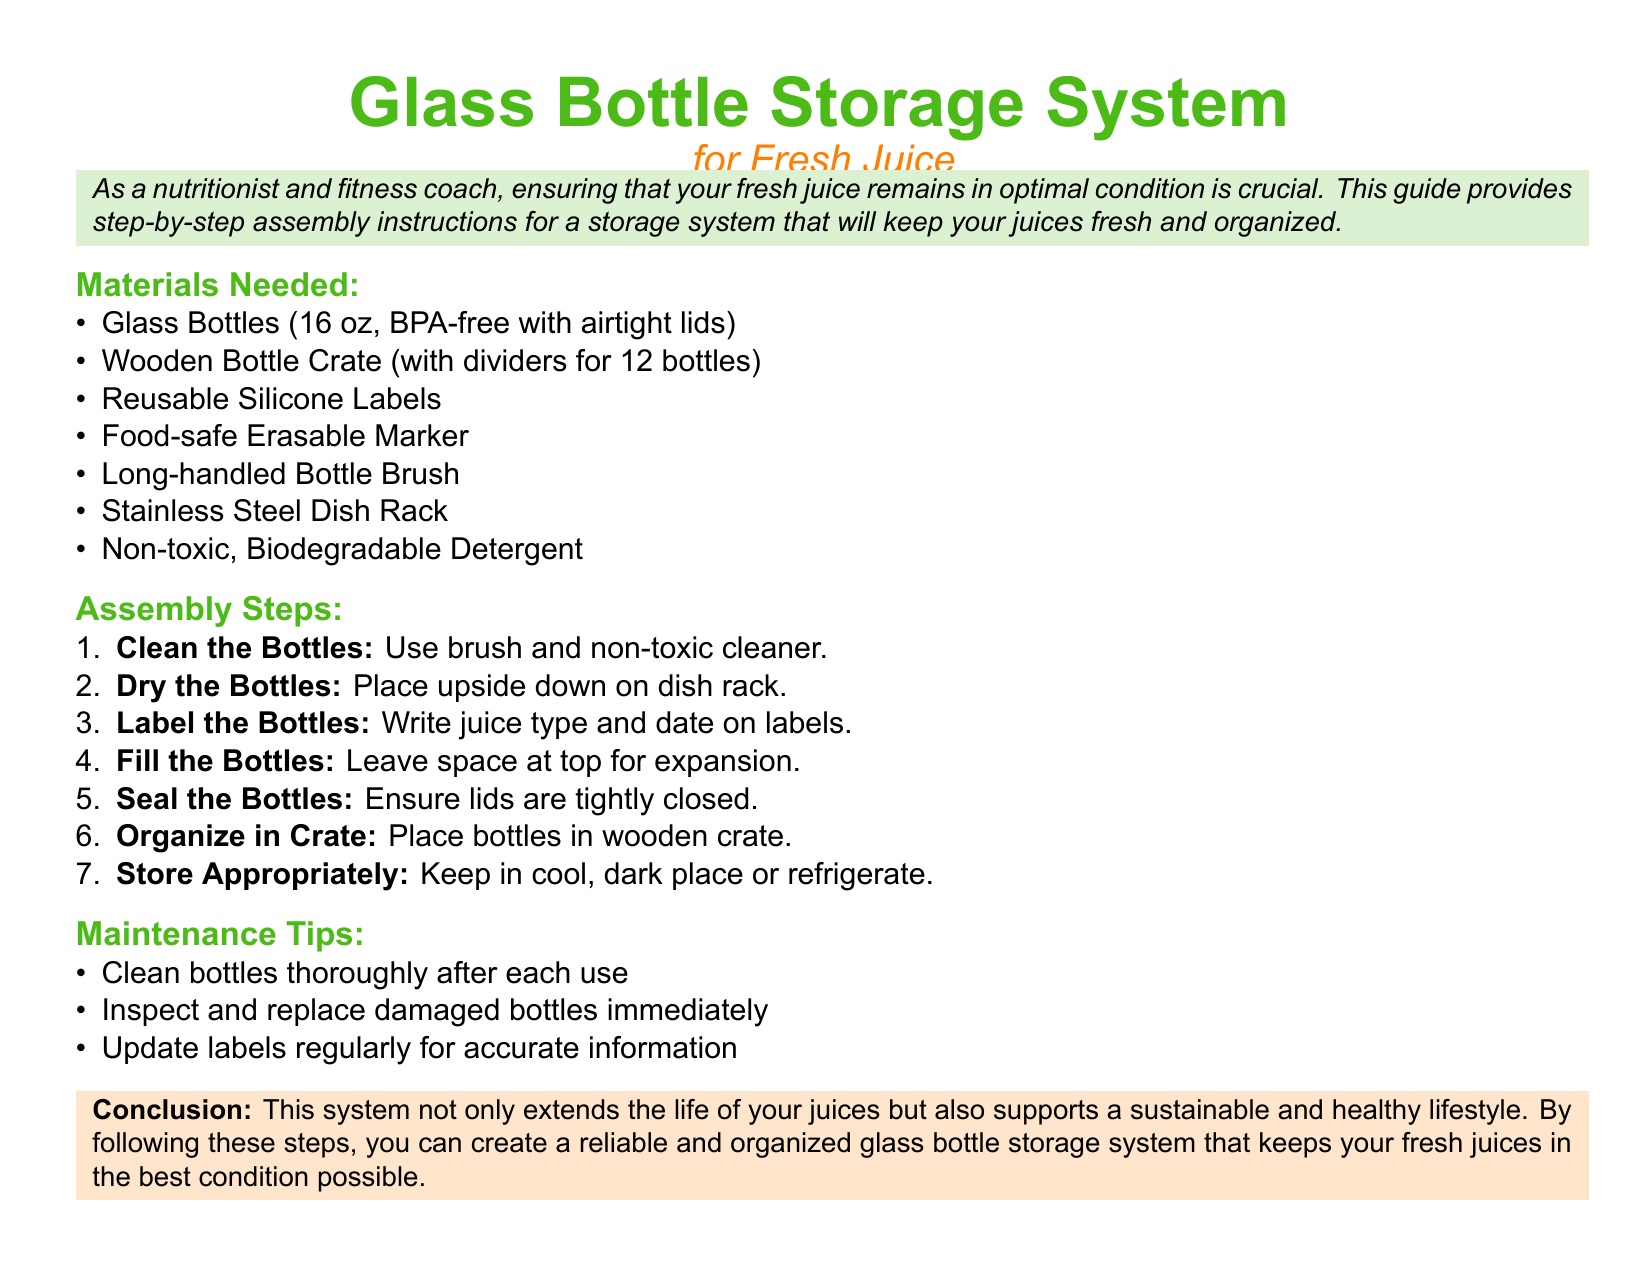what is the capacity of the glass bottles? The glass bottles specified in the document have a capacity of 16 oz.
Answer: 16 oz how many bottles can the wooden crate hold? The wooden bottle crate is designed to hold 12 bottles.
Answer: 12 bottles what should you use to label the bottles? The document suggests using reusable silicone labels and a food-safe erasable marker for labeling.
Answer: reusable silicone labels what is the first step in the assembly process? The first step outlined in the assembly instructions is to clean the bottles.
Answer: Clean the Bottles what should you leave at the top of the bottles when filling? The document advises leaving space at the top of the bottles for expansion.
Answer: space for expansion what type of detergent is recommended for cleaning? A non-toxic, biodegradable detergent is recommended for cleaning the bottles.
Answer: non-toxic, biodegradable detergent why is it important to inspect bottles regularly? Regular inspection is necessary to replace damaged bottles immediately, ensuring freshness.
Answer: replace damaged bottles immediately what is the purpose of the guide? The guide aims to provide step-by-step assembly instructions for a storage system to keep juices fresh and organized.
Answer: keep juices fresh and organized 